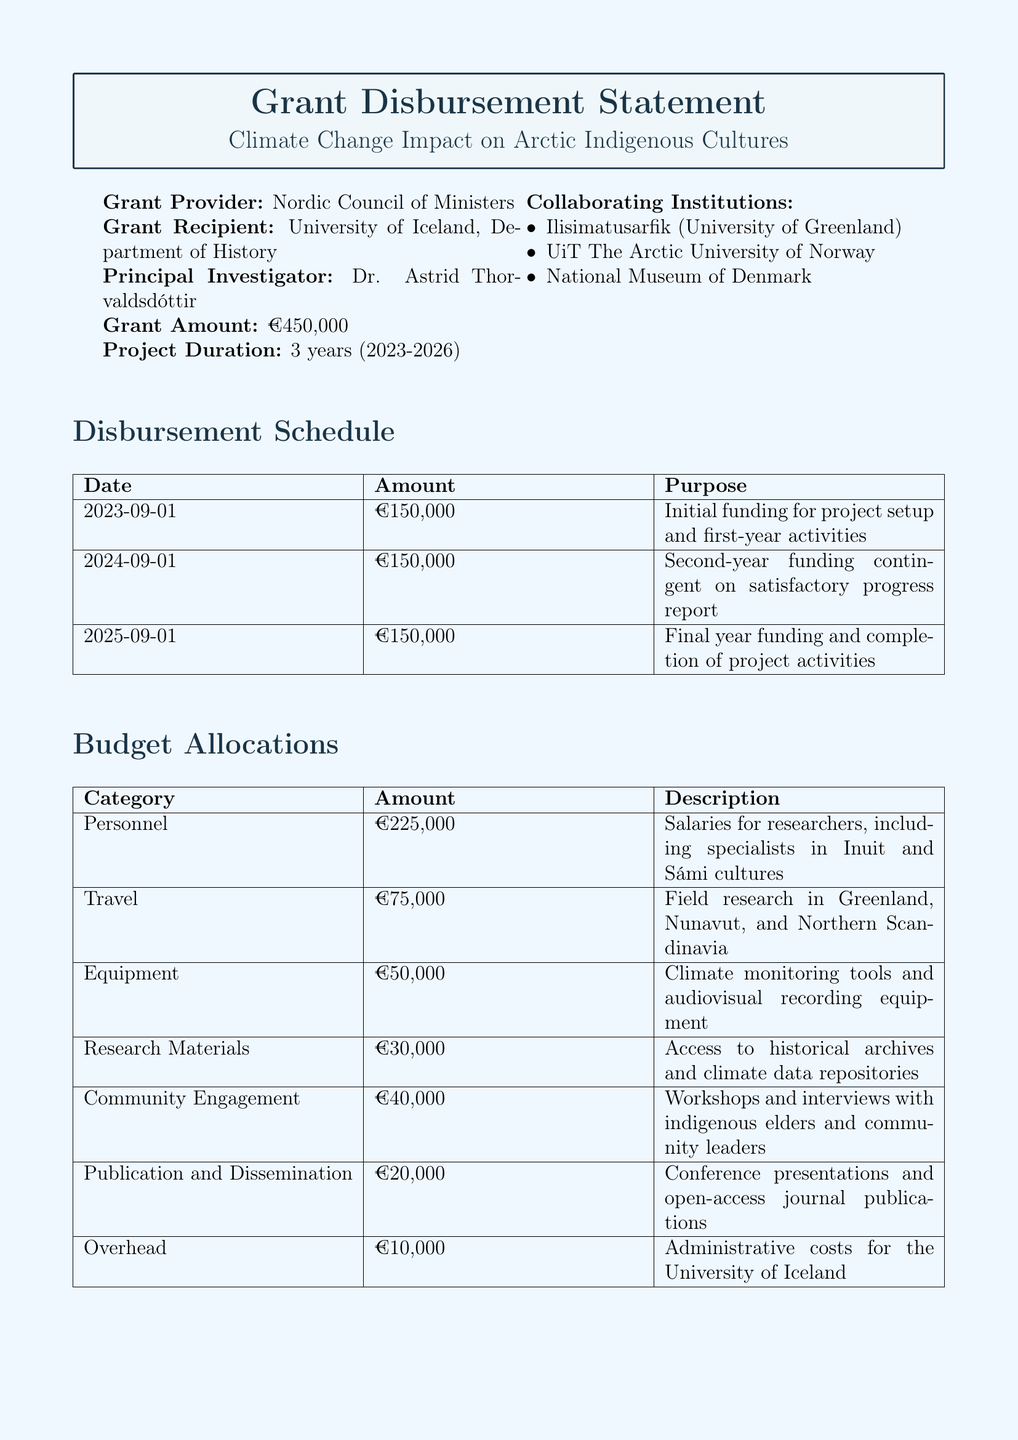What is the title of the project? The title of the project is explicitly stated in the document as the main focus of the grant disbursement statement.
Answer: Climate Change Impact on Arctic Indigenous Cultures Who is the principal investigator? The principal investigator is the individual responsible for the project's oversight, and their name is mentioned directly in the document.
Answer: Dr. Astrid Thorvaldsdóttir How much is the total grant amount? The total grant amount is specified very clearly in the document under the grant details.
Answer: €450,000 What is the purpose of the first disbursement? The purpose of the first disbursement is detailed in the document in the disbursement schedule section, indicating what the initial funds will be used for.
Answer: Initial funding for project setup and first-year activities Which institution is collaborating with the University of Iceland? The document lists the collaborating institutions in a specific section, allowing for identification of partners involved in the project.
Answer: Ilisimatusarfik (University of Greenland) How many years will the project last? The project duration is stated in the document, specifying the length of time allocated for the project.
Answer: 3 years (2023-2026) When is the due date for the final project report? The due date for the final project report is noted in the reporting requirements section of the document, indicating when the final submission is expected.
Answer: December 31, 2026 What category has the highest budget allocation? The highest budget allocation is identified through the budget allocations section of the document, allowing for comparison among categories.
Answer: Personnel What is the budget amount allocated for travel? The document includes specific information about budget allocations for different categories, including travel.
Answer: €75,000 